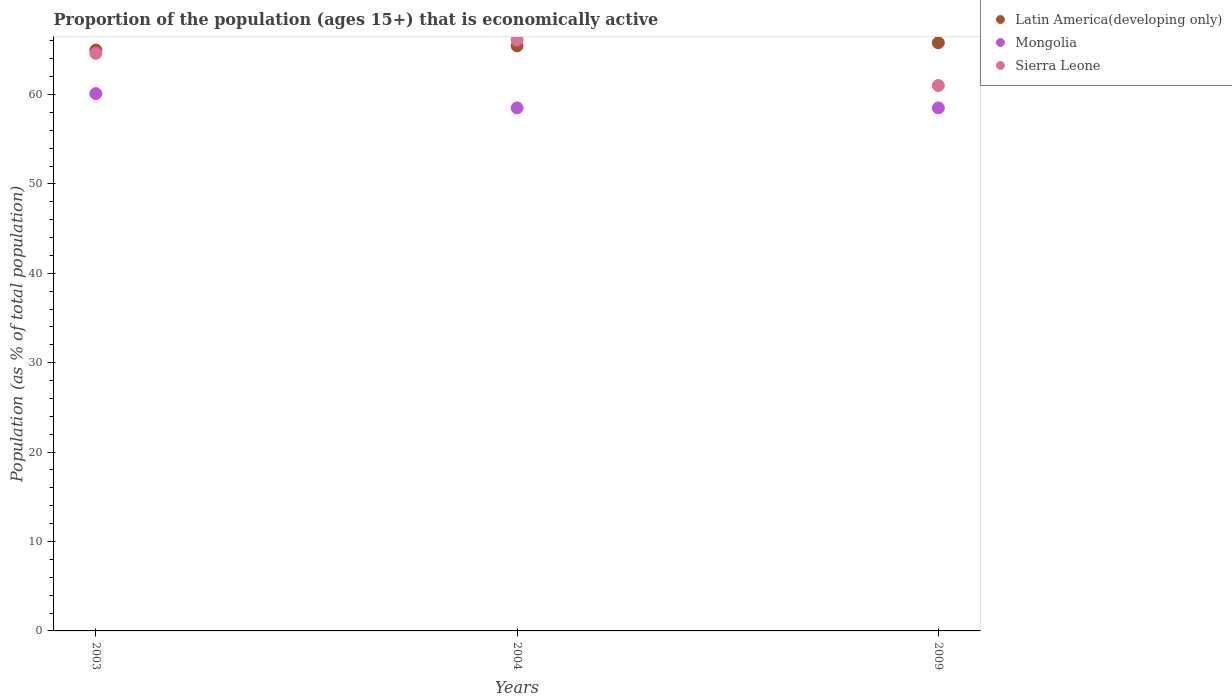How many different coloured dotlines are there?
Offer a very short reply. 3. Is the number of dotlines equal to the number of legend labels?
Your answer should be very brief. Yes. Across all years, what is the maximum proportion of the population that is economically active in Sierra Leone?
Your response must be concise. 66.1. Across all years, what is the minimum proportion of the population that is economically active in Sierra Leone?
Offer a very short reply. 61. In which year was the proportion of the population that is economically active in Latin America(developing only) maximum?
Give a very brief answer. 2009. In which year was the proportion of the population that is economically active in Latin America(developing only) minimum?
Offer a very short reply. 2003. What is the total proportion of the population that is economically active in Mongolia in the graph?
Offer a very short reply. 177.1. What is the difference between the proportion of the population that is economically active in Latin America(developing only) in 2003 and that in 2004?
Offer a terse response. -0.47. What is the difference between the proportion of the population that is economically active in Sierra Leone in 2004 and the proportion of the population that is economically active in Mongolia in 2009?
Offer a very short reply. 7.6. What is the average proportion of the population that is economically active in Sierra Leone per year?
Keep it short and to the point. 63.9. In the year 2009, what is the difference between the proportion of the population that is economically active in Latin America(developing only) and proportion of the population that is economically active in Mongolia?
Offer a terse response. 7.29. In how many years, is the proportion of the population that is economically active in Latin America(developing only) greater than 14 %?
Provide a short and direct response. 3. What is the ratio of the proportion of the population that is economically active in Sierra Leone in 2003 to that in 2009?
Your answer should be very brief. 1.06. What is the difference between the highest and the second highest proportion of the population that is economically active in Mongolia?
Make the answer very short. 1.6. What is the difference between the highest and the lowest proportion of the population that is economically active in Sierra Leone?
Offer a terse response. 5.1. Is the sum of the proportion of the population that is economically active in Mongolia in 2004 and 2009 greater than the maximum proportion of the population that is economically active in Sierra Leone across all years?
Offer a terse response. Yes. Is the proportion of the population that is economically active in Latin America(developing only) strictly less than the proportion of the population that is economically active in Mongolia over the years?
Your answer should be very brief. No. How many years are there in the graph?
Provide a short and direct response. 3. Does the graph contain any zero values?
Your response must be concise. No. Where does the legend appear in the graph?
Provide a short and direct response. Top right. How many legend labels are there?
Your answer should be very brief. 3. What is the title of the graph?
Offer a terse response. Proportion of the population (ages 15+) that is economically active. Does "Guam" appear as one of the legend labels in the graph?
Provide a short and direct response. No. What is the label or title of the X-axis?
Keep it short and to the point. Years. What is the label or title of the Y-axis?
Your response must be concise. Population (as % of total population). What is the Population (as % of total population) in Latin America(developing only) in 2003?
Offer a very short reply. 64.96. What is the Population (as % of total population) in Mongolia in 2003?
Offer a very short reply. 60.1. What is the Population (as % of total population) in Sierra Leone in 2003?
Your answer should be compact. 64.6. What is the Population (as % of total population) of Latin America(developing only) in 2004?
Offer a terse response. 65.43. What is the Population (as % of total population) of Mongolia in 2004?
Offer a very short reply. 58.5. What is the Population (as % of total population) in Sierra Leone in 2004?
Ensure brevity in your answer.  66.1. What is the Population (as % of total population) of Latin America(developing only) in 2009?
Your answer should be compact. 65.79. What is the Population (as % of total population) of Mongolia in 2009?
Your answer should be very brief. 58.5. What is the Population (as % of total population) in Sierra Leone in 2009?
Keep it short and to the point. 61. Across all years, what is the maximum Population (as % of total population) of Latin America(developing only)?
Offer a very short reply. 65.79. Across all years, what is the maximum Population (as % of total population) of Mongolia?
Provide a short and direct response. 60.1. Across all years, what is the maximum Population (as % of total population) of Sierra Leone?
Ensure brevity in your answer.  66.1. Across all years, what is the minimum Population (as % of total population) of Latin America(developing only)?
Give a very brief answer. 64.96. Across all years, what is the minimum Population (as % of total population) of Mongolia?
Offer a very short reply. 58.5. What is the total Population (as % of total population) of Latin America(developing only) in the graph?
Make the answer very short. 196.19. What is the total Population (as % of total population) of Mongolia in the graph?
Keep it short and to the point. 177.1. What is the total Population (as % of total population) in Sierra Leone in the graph?
Your response must be concise. 191.7. What is the difference between the Population (as % of total population) in Latin America(developing only) in 2003 and that in 2004?
Your response must be concise. -0.47. What is the difference between the Population (as % of total population) in Mongolia in 2003 and that in 2004?
Provide a short and direct response. 1.6. What is the difference between the Population (as % of total population) of Latin America(developing only) in 2003 and that in 2009?
Make the answer very short. -0.82. What is the difference between the Population (as % of total population) in Sierra Leone in 2003 and that in 2009?
Offer a very short reply. 3.6. What is the difference between the Population (as % of total population) of Latin America(developing only) in 2004 and that in 2009?
Your response must be concise. -0.35. What is the difference between the Population (as % of total population) of Latin America(developing only) in 2003 and the Population (as % of total population) of Mongolia in 2004?
Make the answer very short. 6.46. What is the difference between the Population (as % of total population) in Latin America(developing only) in 2003 and the Population (as % of total population) in Sierra Leone in 2004?
Provide a succinct answer. -1.14. What is the difference between the Population (as % of total population) of Mongolia in 2003 and the Population (as % of total population) of Sierra Leone in 2004?
Your answer should be compact. -6. What is the difference between the Population (as % of total population) of Latin America(developing only) in 2003 and the Population (as % of total population) of Mongolia in 2009?
Provide a succinct answer. 6.46. What is the difference between the Population (as % of total population) of Latin America(developing only) in 2003 and the Population (as % of total population) of Sierra Leone in 2009?
Your answer should be very brief. 3.96. What is the difference between the Population (as % of total population) in Mongolia in 2003 and the Population (as % of total population) in Sierra Leone in 2009?
Make the answer very short. -0.9. What is the difference between the Population (as % of total population) in Latin America(developing only) in 2004 and the Population (as % of total population) in Mongolia in 2009?
Provide a short and direct response. 6.93. What is the difference between the Population (as % of total population) of Latin America(developing only) in 2004 and the Population (as % of total population) of Sierra Leone in 2009?
Provide a short and direct response. 4.43. What is the average Population (as % of total population) of Latin America(developing only) per year?
Keep it short and to the point. 65.4. What is the average Population (as % of total population) of Mongolia per year?
Make the answer very short. 59.03. What is the average Population (as % of total population) in Sierra Leone per year?
Give a very brief answer. 63.9. In the year 2003, what is the difference between the Population (as % of total population) in Latin America(developing only) and Population (as % of total population) in Mongolia?
Offer a very short reply. 4.86. In the year 2003, what is the difference between the Population (as % of total population) in Latin America(developing only) and Population (as % of total population) in Sierra Leone?
Ensure brevity in your answer.  0.36. In the year 2004, what is the difference between the Population (as % of total population) of Latin America(developing only) and Population (as % of total population) of Mongolia?
Your answer should be compact. 6.93. In the year 2004, what is the difference between the Population (as % of total population) in Latin America(developing only) and Population (as % of total population) in Sierra Leone?
Offer a very short reply. -0.67. In the year 2004, what is the difference between the Population (as % of total population) in Mongolia and Population (as % of total population) in Sierra Leone?
Keep it short and to the point. -7.6. In the year 2009, what is the difference between the Population (as % of total population) of Latin America(developing only) and Population (as % of total population) of Mongolia?
Make the answer very short. 7.29. In the year 2009, what is the difference between the Population (as % of total population) in Latin America(developing only) and Population (as % of total population) in Sierra Leone?
Provide a short and direct response. 4.79. In the year 2009, what is the difference between the Population (as % of total population) in Mongolia and Population (as % of total population) in Sierra Leone?
Offer a very short reply. -2.5. What is the ratio of the Population (as % of total population) of Latin America(developing only) in 2003 to that in 2004?
Your answer should be very brief. 0.99. What is the ratio of the Population (as % of total population) in Mongolia in 2003 to that in 2004?
Provide a short and direct response. 1.03. What is the ratio of the Population (as % of total population) in Sierra Leone in 2003 to that in 2004?
Ensure brevity in your answer.  0.98. What is the ratio of the Population (as % of total population) of Latin America(developing only) in 2003 to that in 2009?
Your answer should be compact. 0.99. What is the ratio of the Population (as % of total population) of Mongolia in 2003 to that in 2009?
Provide a succinct answer. 1.03. What is the ratio of the Population (as % of total population) in Sierra Leone in 2003 to that in 2009?
Your answer should be very brief. 1.06. What is the ratio of the Population (as % of total population) of Sierra Leone in 2004 to that in 2009?
Keep it short and to the point. 1.08. What is the difference between the highest and the second highest Population (as % of total population) in Latin America(developing only)?
Your answer should be compact. 0.35. What is the difference between the highest and the second highest Population (as % of total population) in Sierra Leone?
Your response must be concise. 1.5. What is the difference between the highest and the lowest Population (as % of total population) of Latin America(developing only)?
Offer a terse response. 0.82. What is the difference between the highest and the lowest Population (as % of total population) in Mongolia?
Provide a succinct answer. 1.6. What is the difference between the highest and the lowest Population (as % of total population) of Sierra Leone?
Offer a very short reply. 5.1. 